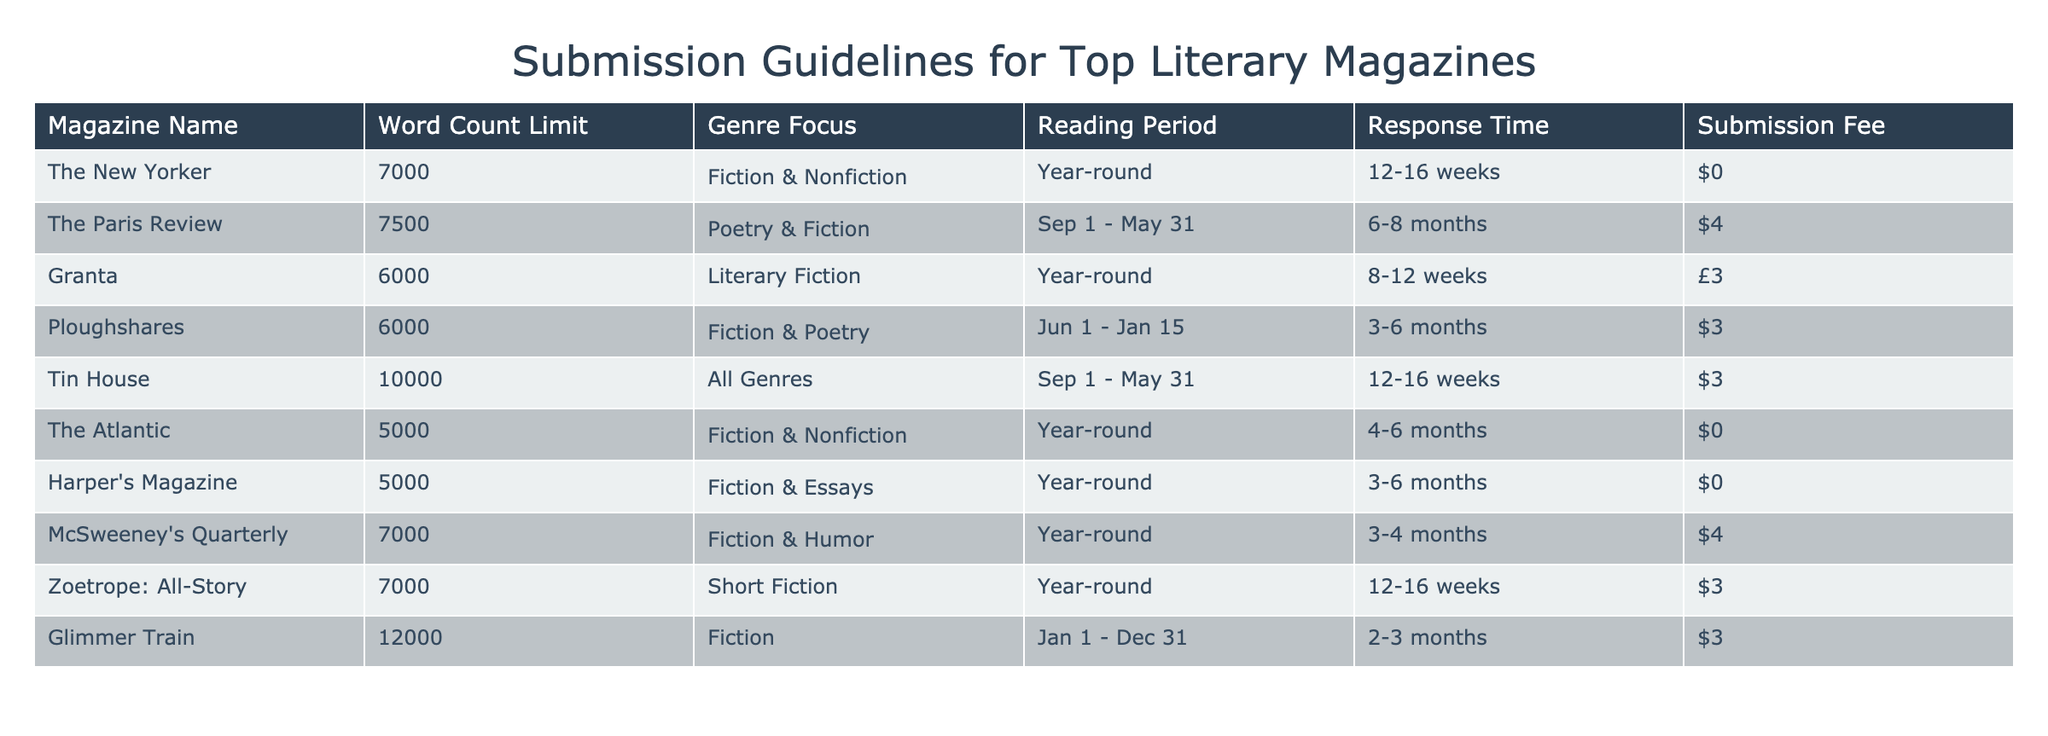What is the word count limit for The New Yorker? The table lists the word count limit for each magazine, and for The New Yorker, it is specified as 7000 words.
Answer: 7000 Which magazines have a submission fee of $0? By checking the "Submission Fee" column for $0 values, we find that The New Yorker, The Atlantic, and Harper's Magazine do not charge a submission fee.
Answer: The New Yorker, The Atlantic, Harper's Magazine What is the average word count limit among the magazines listed? The word count limits from the table are: 7000, 7500, 6000, 6000, 10000, 5000, 5000, 7000, 7000, 12000. Summing these (7000 + 7500 + 6000 + 6000 + 10000 + 5000 + 5000 + 7000 + 7000 + 12000 = 68000) and dividing by the number of magazines (10) gives an average of 6800.
Answer: 6800 Is Granta focused on poetry? The genre focus for Granta is Literary Fiction, so it does not focus on poetry specifically.
Answer: No Which magazine has the longest response time, and how long is it? The longest response time in the table is for The Paris Review, which is listed as 6-8 months. We identify this by comparing the "Response Time" column for the maximum duration.
Answer: The Paris Review, 6-8 months How many magazines have a reading period from September to May? By checking the "Reading Period" column, we see that two magazines—The Paris Review and Tin House—have reading periods listed as September to May.
Answer: 2 What is the total submission fee for all magazines that charge a fee? The submission fees are $4 for The Paris Review, $3 for Ploughshares, $3 for McSweeney's Quarterly, and $3 for Zoetrope: All-Story. Adding these fees gives $4 + $3 + $3 + $3 = $13.
Answer: $13 Does Glimmer Train accept submissions year-round? In the "Reading Period" column, Glimmer Train has its reading period listed as Jan 1 - Dec 31, indicating that it accepts submissions year-round.
Answer: Yes Which magazine accepts all genres and what is its word count limit? The magazine that accepts all genres is Tin House, and its word count limit is specified as 10000. This is found by locating the "Genre Focus" entry for Tin House.
Answer: Tin House, 10000 